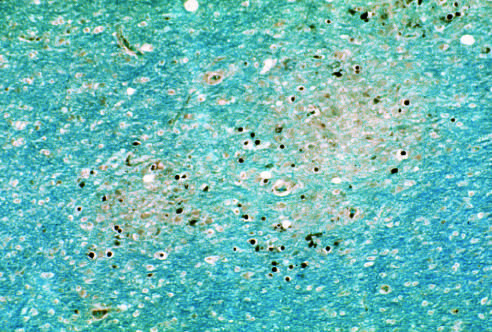do others surround an area of early myelin loss?
Answer the question using a single word or phrase. No 